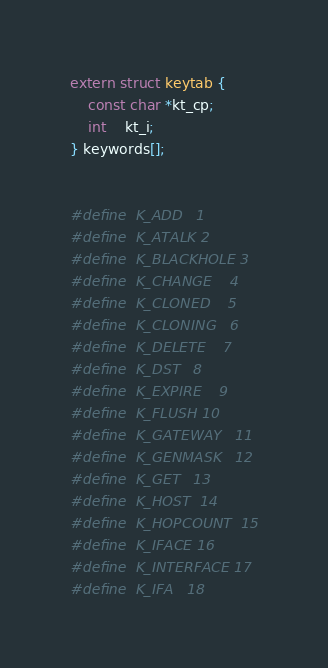Convert code to text. <code><loc_0><loc_0><loc_500><loc_500><_C_>
extern struct keytab {
	const char *kt_cp;
	int	kt_i;
} keywords[];


#define	K_ADD	1
#define	K_ATALK	2
#define	K_BLACKHOLE	3
#define	K_CHANGE	4
#define	K_CLONED	5
#define	K_CLONING	6
#define	K_DELETE	7
#define	K_DST	8
#define	K_EXPIRE	9
#define	K_FLUSH	10
#define	K_GATEWAY	11
#define	K_GENMASK	12
#define	K_GET	13
#define	K_HOST	14
#define	K_HOPCOUNT	15
#define	K_IFACE	16
#define	K_INTERFACE	17
#define	K_IFA	18</code> 